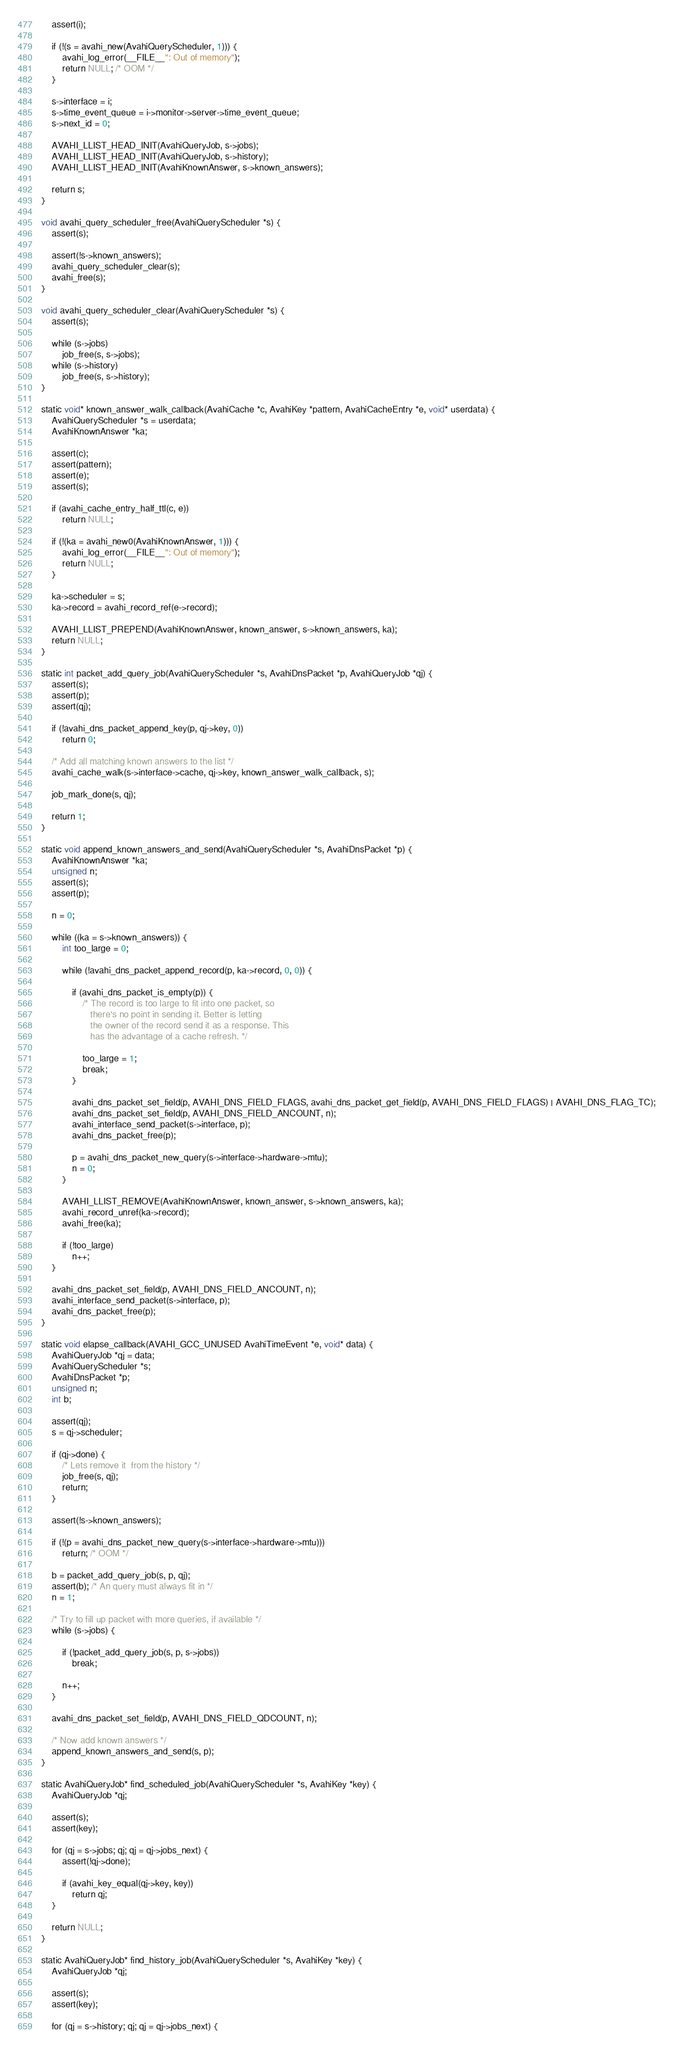Convert code to text. <code><loc_0><loc_0><loc_500><loc_500><_C_>    assert(i);

    if (!(s = avahi_new(AvahiQueryScheduler, 1))) {
        avahi_log_error(__FILE__": Out of memory");
        return NULL; /* OOM */
    }

    s->interface = i;
    s->time_event_queue = i->monitor->server->time_event_queue;
    s->next_id = 0;

    AVAHI_LLIST_HEAD_INIT(AvahiQueryJob, s->jobs);
    AVAHI_LLIST_HEAD_INIT(AvahiQueryJob, s->history);
    AVAHI_LLIST_HEAD_INIT(AvahiKnownAnswer, s->known_answers);

    return s;
}

void avahi_query_scheduler_free(AvahiQueryScheduler *s) {
    assert(s);

    assert(!s->known_answers);
    avahi_query_scheduler_clear(s);
    avahi_free(s);
}

void avahi_query_scheduler_clear(AvahiQueryScheduler *s) {
    assert(s);

    while (s->jobs)
        job_free(s, s->jobs);
    while (s->history)
        job_free(s, s->history);
}

static void* known_answer_walk_callback(AvahiCache *c, AvahiKey *pattern, AvahiCacheEntry *e, void* userdata) {
    AvahiQueryScheduler *s = userdata;
    AvahiKnownAnswer *ka;

    assert(c);
    assert(pattern);
    assert(e);
    assert(s);

    if (avahi_cache_entry_half_ttl(c, e))
        return NULL;

    if (!(ka = avahi_new0(AvahiKnownAnswer, 1))) {
        avahi_log_error(__FILE__": Out of memory");
        return NULL;
    }

    ka->scheduler = s;
    ka->record = avahi_record_ref(e->record);

    AVAHI_LLIST_PREPEND(AvahiKnownAnswer, known_answer, s->known_answers, ka);
    return NULL;
}

static int packet_add_query_job(AvahiQueryScheduler *s, AvahiDnsPacket *p, AvahiQueryJob *qj) {
    assert(s);
    assert(p);
    assert(qj);

    if (!avahi_dns_packet_append_key(p, qj->key, 0))
        return 0;

    /* Add all matching known answers to the list */
    avahi_cache_walk(s->interface->cache, qj->key, known_answer_walk_callback, s);

    job_mark_done(s, qj);

    return 1;
}

static void append_known_answers_and_send(AvahiQueryScheduler *s, AvahiDnsPacket *p) {
    AvahiKnownAnswer *ka;
    unsigned n;
    assert(s);
    assert(p);

    n = 0;

    while ((ka = s->known_answers)) {
        int too_large = 0;

        while (!avahi_dns_packet_append_record(p, ka->record, 0, 0)) {

            if (avahi_dns_packet_is_empty(p)) {
                /* The record is too large to fit into one packet, so
                   there's no point in sending it. Better is letting
                   the owner of the record send it as a response. This
                   has the advantage of a cache refresh. */

                too_large = 1;
                break;
            }

            avahi_dns_packet_set_field(p, AVAHI_DNS_FIELD_FLAGS, avahi_dns_packet_get_field(p, AVAHI_DNS_FIELD_FLAGS) | AVAHI_DNS_FLAG_TC);
            avahi_dns_packet_set_field(p, AVAHI_DNS_FIELD_ANCOUNT, n);
            avahi_interface_send_packet(s->interface, p);
            avahi_dns_packet_free(p);

            p = avahi_dns_packet_new_query(s->interface->hardware->mtu);
            n = 0;
        }

        AVAHI_LLIST_REMOVE(AvahiKnownAnswer, known_answer, s->known_answers, ka);
        avahi_record_unref(ka->record);
        avahi_free(ka);

        if (!too_large)
            n++;
    }

    avahi_dns_packet_set_field(p, AVAHI_DNS_FIELD_ANCOUNT, n);
    avahi_interface_send_packet(s->interface, p);
    avahi_dns_packet_free(p);
}

static void elapse_callback(AVAHI_GCC_UNUSED AvahiTimeEvent *e, void* data) {
    AvahiQueryJob *qj = data;
    AvahiQueryScheduler *s;
    AvahiDnsPacket *p;
    unsigned n;
    int b;

    assert(qj);
    s = qj->scheduler;

    if (qj->done) {
        /* Lets remove it  from the history */
        job_free(s, qj);
        return;
    }

    assert(!s->known_answers);

    if (!(p = avahi_dns_packet_new_query(s->interface->hardware->mtu)))
        return; /* OOM */

    b = packet_add_query_job(s, p, qj);
    assert(b); /* An query must always fit in */
    n = 1;

    /* Try to fill up packet with more queries, if available */
    while (s->jobs) {

        if (!packet_add_query_job(s, p, s->jobs))
            break;

        n++;
    }

    avahi_dns_packet_set_field(p, AVAHI_DNS_FIELD_QDCOUNT, n);

    /* Now add known answers */
    append_known_answers_and_send(s, p);
}

static AvahiQueryJob* find_scheduled_job(AvahiQueryScheduler *s, AvahiKey *key) {
    AvahiQueryJob *qj;

    assert(s);
    assert(key);

    for (qj = s->jobs; qj; qj = qj->jobs_next) {
        assert(!qj->done);

        if (avahi_key_equal(qj->key, key))
            return qj;
    }

    return NULL;
}

static AvahiQueryJob* find_history_job(AvahiQueryScheduler *s, AvahiKey *key) {
    AvahiQueryJob *qj;

    assert(s);
    assert(key);

    for (qj = s->history; qj; qj = qj->jobs_next) {</code> 